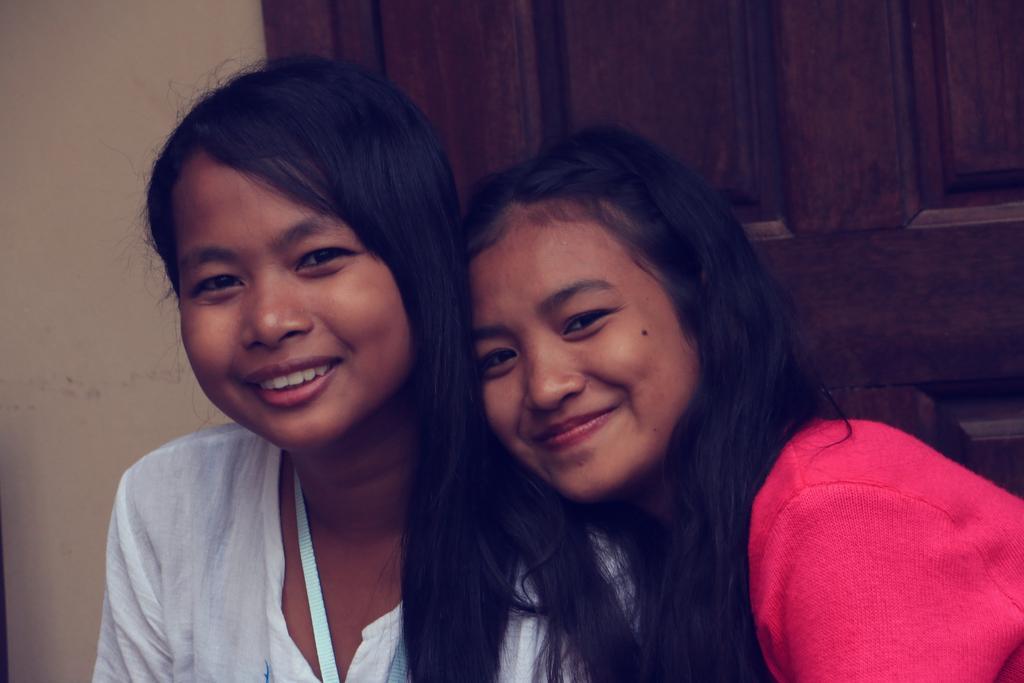Please provide a concise description of this image. In this image in the front there are persons smiling. In the background there is door. 